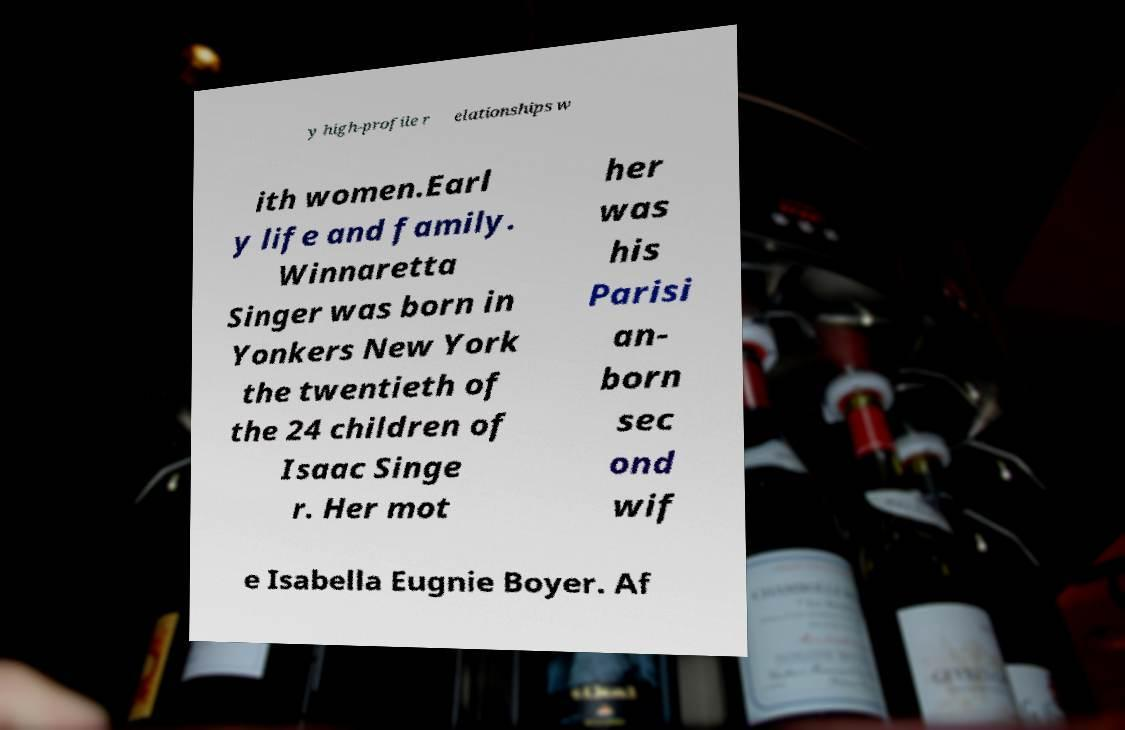What messages or text are displayed in this image? I need them in a readable, typed format. y high-profile r elationships w ith women.Earl y life and family. Winnaretta Singer was born in Yonkers New York the twentieth of the 24 children of Isaac Singe r. Her mot her was his Parisi an- born sec ond wif e Isabella Eugnie Boyer. Af 